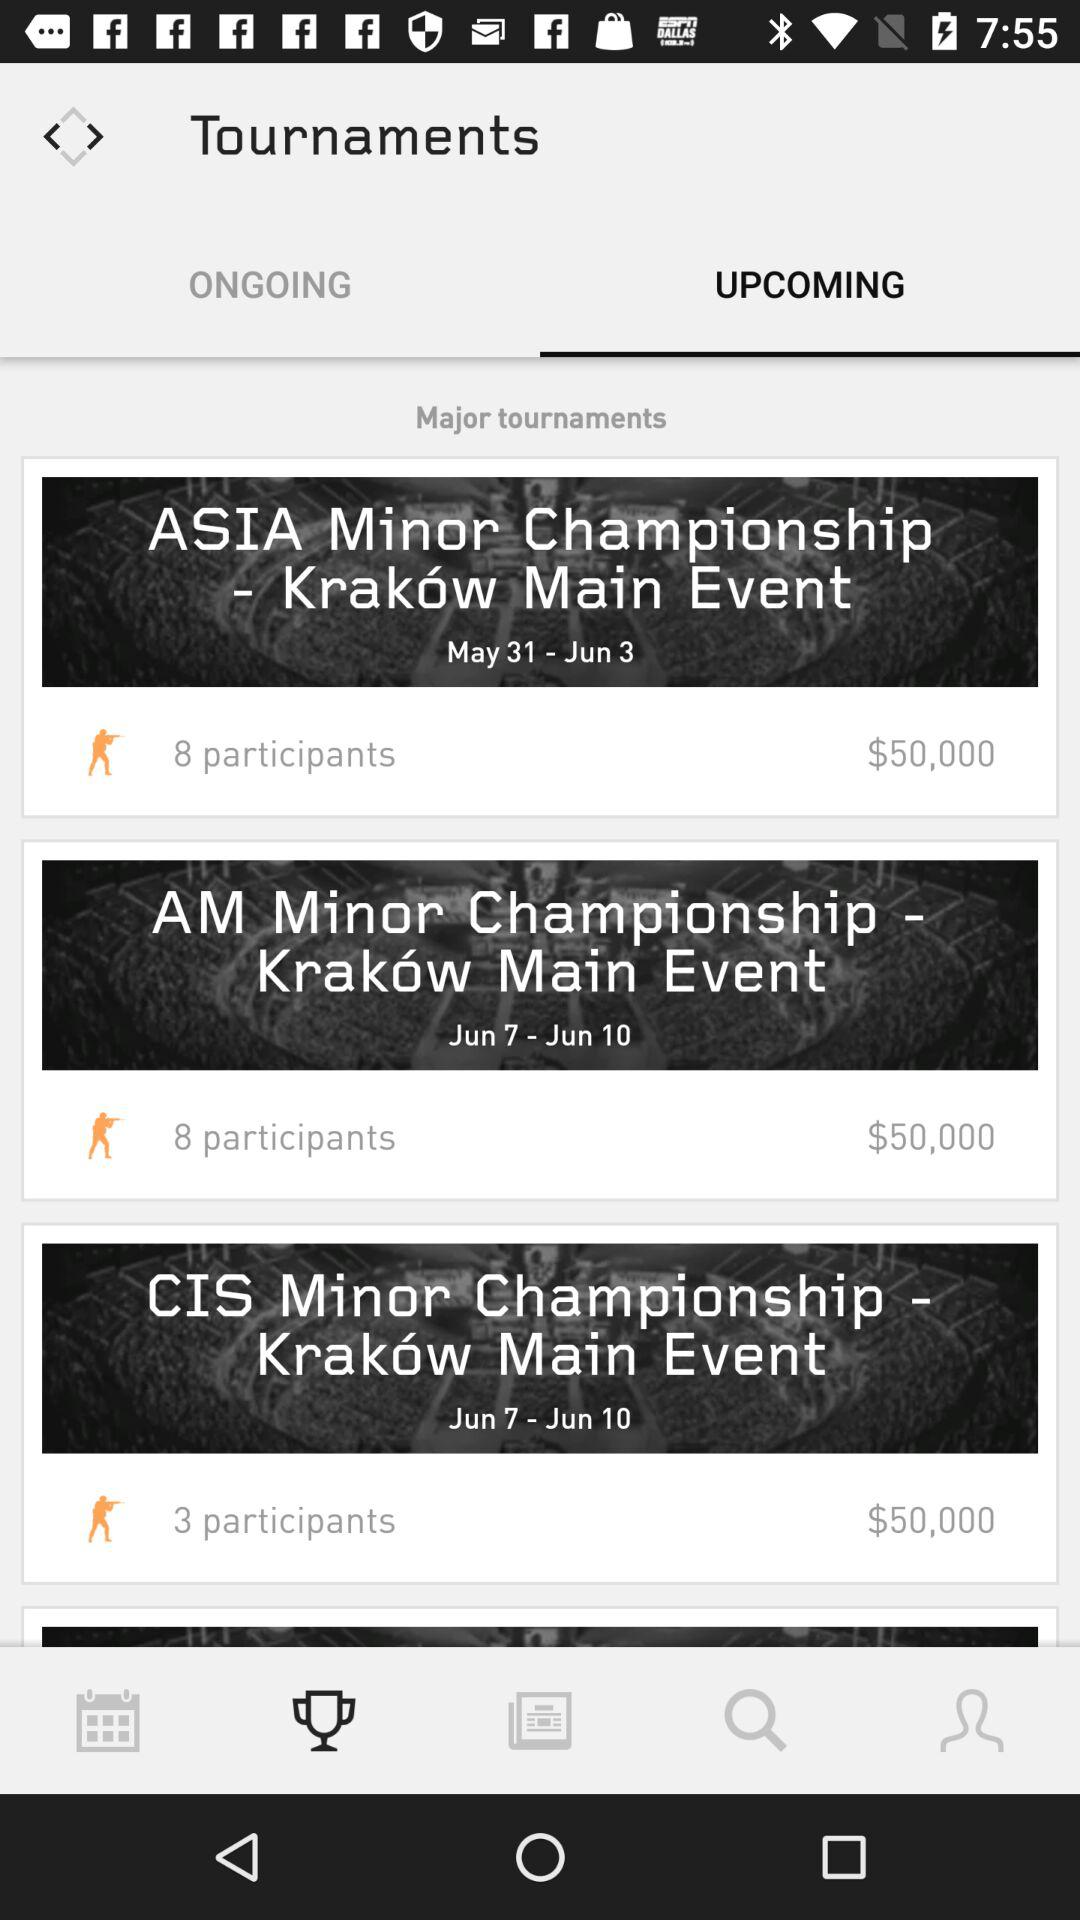How many more participants are there in the ASIA Minor Championship than the CIS Minor Championship?
Answer the question using a single word or phrase. 5 